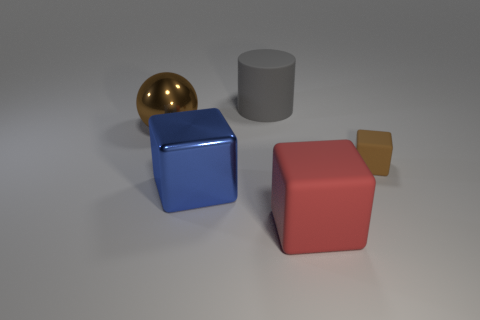What number of objects are either green rubber cubes or tiny cubes?
Provide a succinct answer. 1. There is a rubber cylinder; is it the same size as the metal object that is in front of the brown ball?
Keep it short and to the point. Yes. What color is the metal thing that is in front of the brown thing right of the matte object that is left of the large red rubber object?
Your response must be concise. Blue. The large cylinder has what color?
Your response must be concise. Gray. Are there more rubber objects that are on the left side of the large red thing than tiny matte blocks that are behind the small matte block?
Provide a succinct answer. Yes. Does the tiny brown matte object have the same shape as the big metallic object left of the large blue shiny thing?
Provide a short and direct response. No. There is a brown thing that is left of the brown matte object; is it the same size as the brown thing that is right of the large blue block?
Offer a very short reply. No. There is a matte thing behind the brown object to the left of the tiny matte thing; are there any large red cubes left of it?
Keep it short and to the point. No. Is the number of large gray cylinders that are behind the rubber cylinder less than the number of rubber blocks that are left of the sphere?
Your response must be concise. No. There is a red object that is the same material as the tiny brown cube; what shape is it?
Offer a terse response. Cube. 